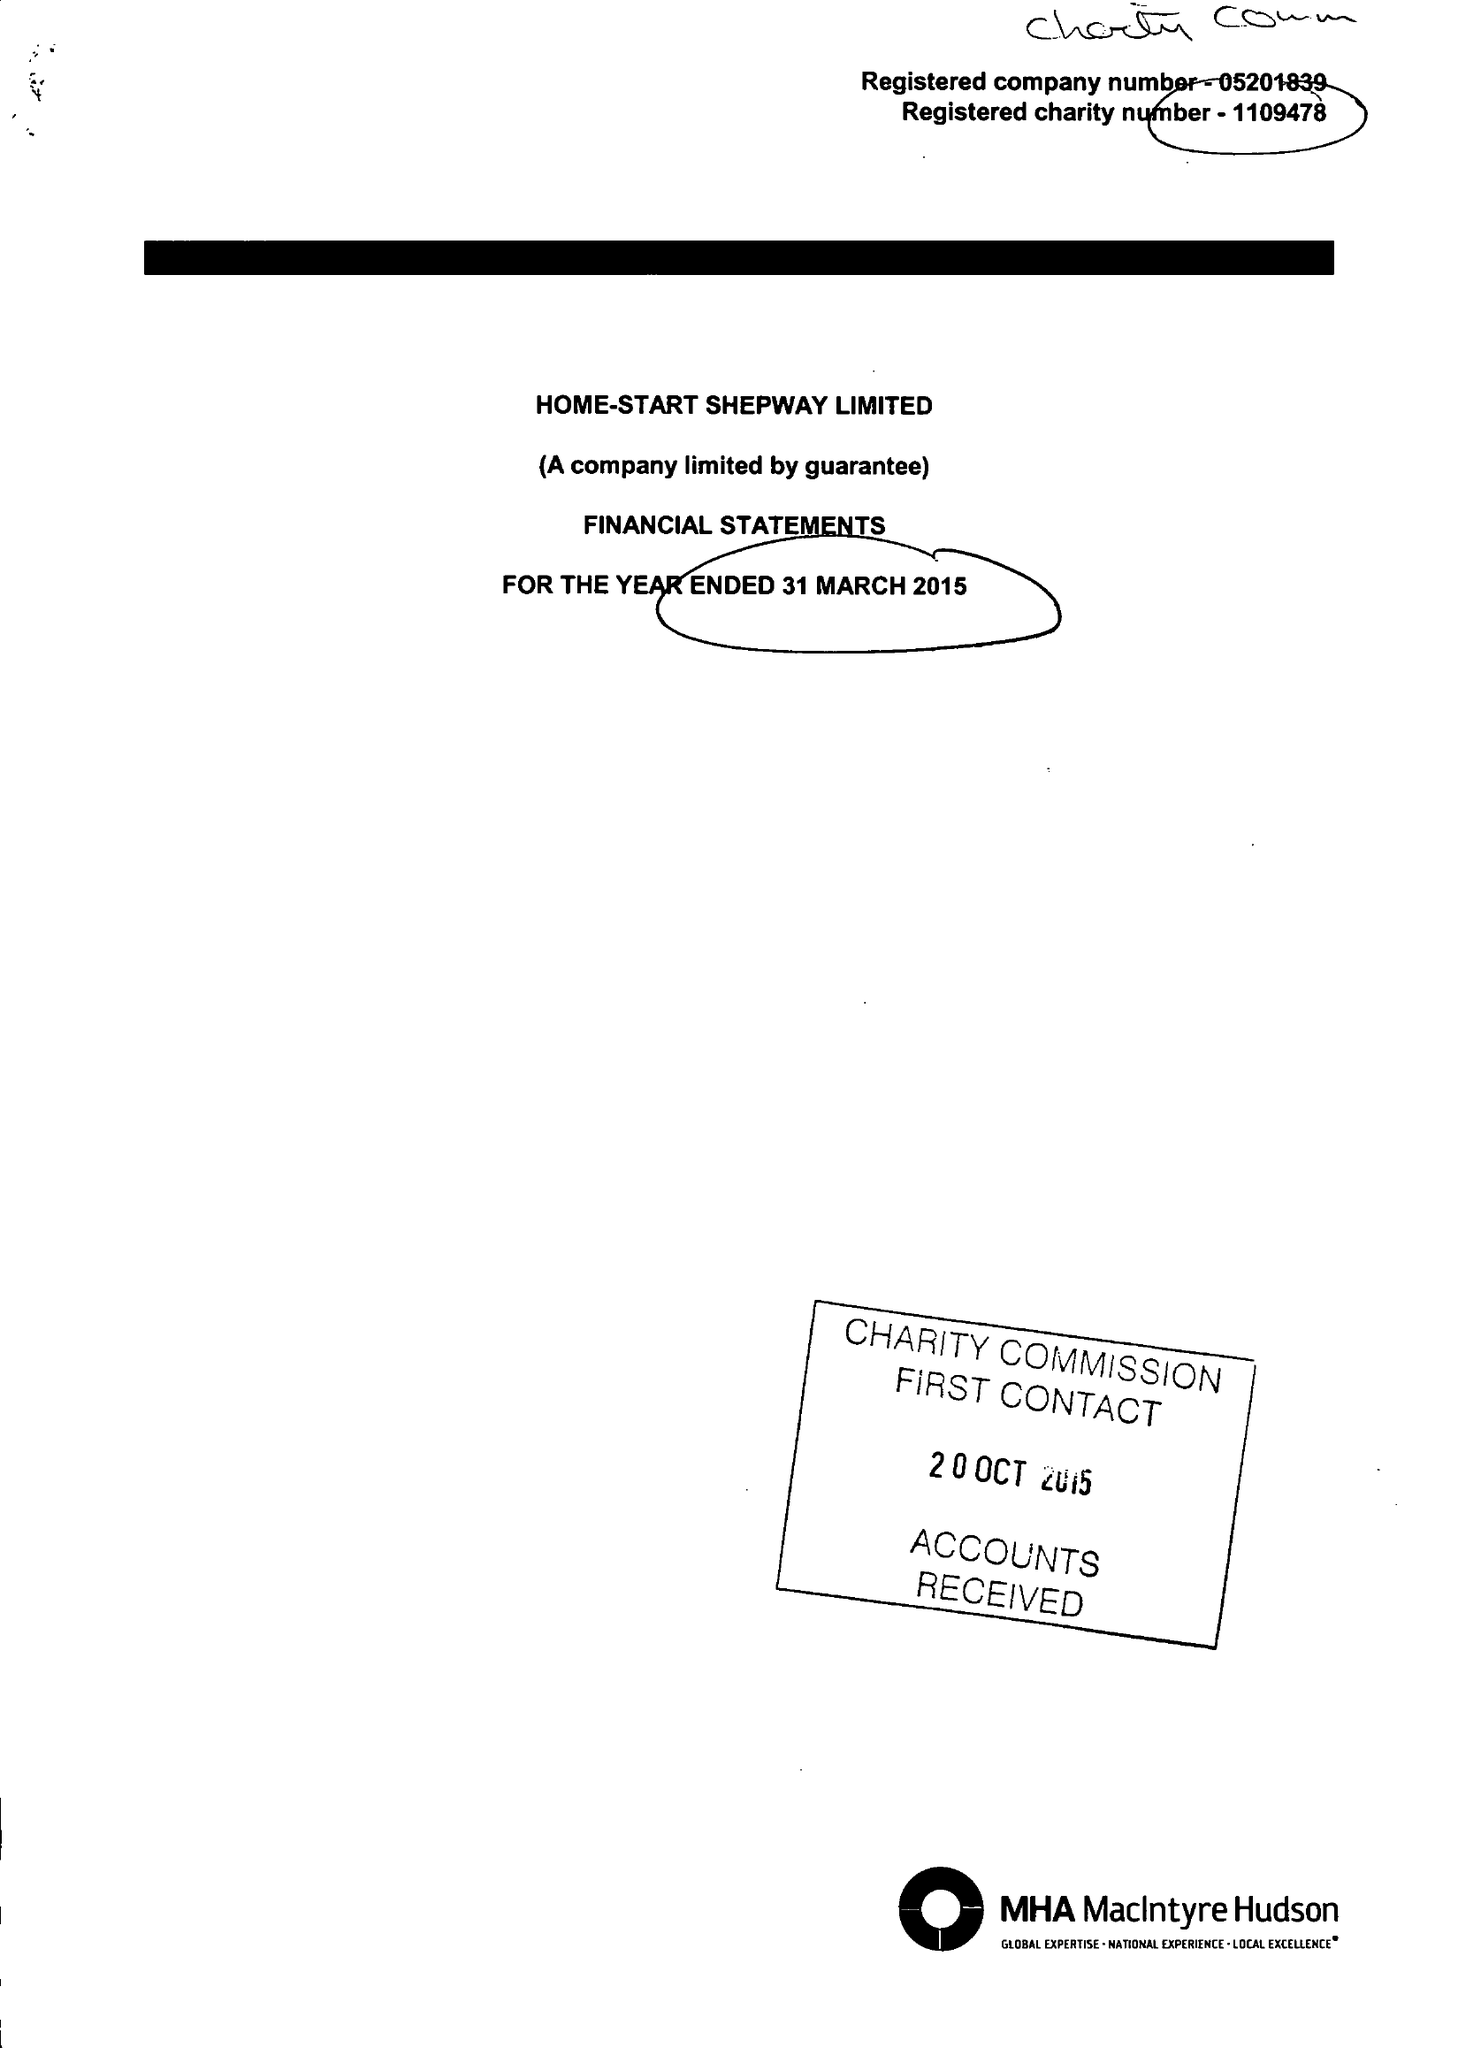What is the value for the income_annually_in_british_pounds?
Answer the question using a single word or phrase. 385240.00 